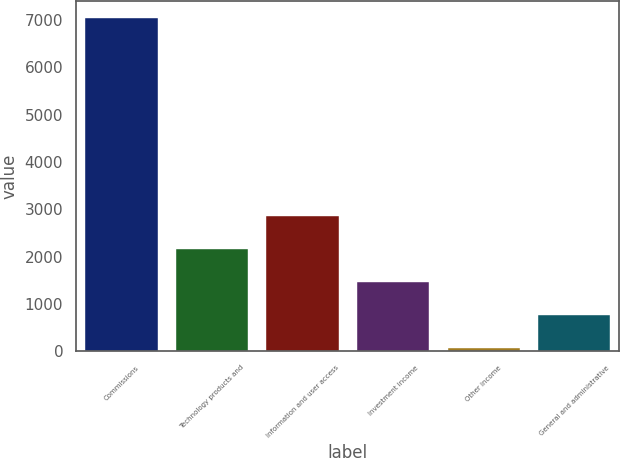<chart> <loc_0><loc_0><loc_500><loc_500><bar_chart><fcel>Commissions<fcel>Technology products and<fcel>Information and user access<fcel>Investment income<fcel>Other income<fcel>General and administrative<nl><fcel>7045<fcel>2159.7<fcel>2857.6<fcel>1461.8<fcel>66<fcel>763.9<nl></chart> 